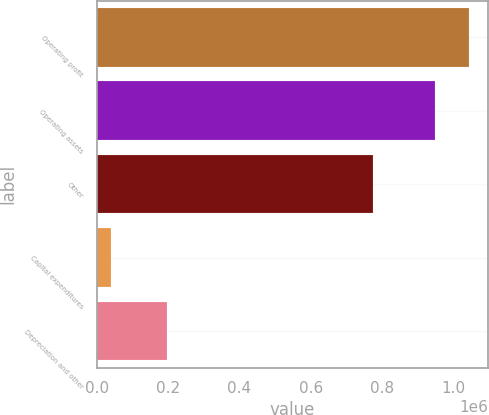<chart> <loc_0><loc_0><loc_500><loc_500><bar_chart><fcel>Operating profit<fcel>Operating assets<fcel>Other<fcel>Capital expenditures<fcel>Depreciation and other<nl><fcel>1.04542e+06<fcel>949239<fcel>774275<fcel>37644<fcel>197284<nl></chart> 